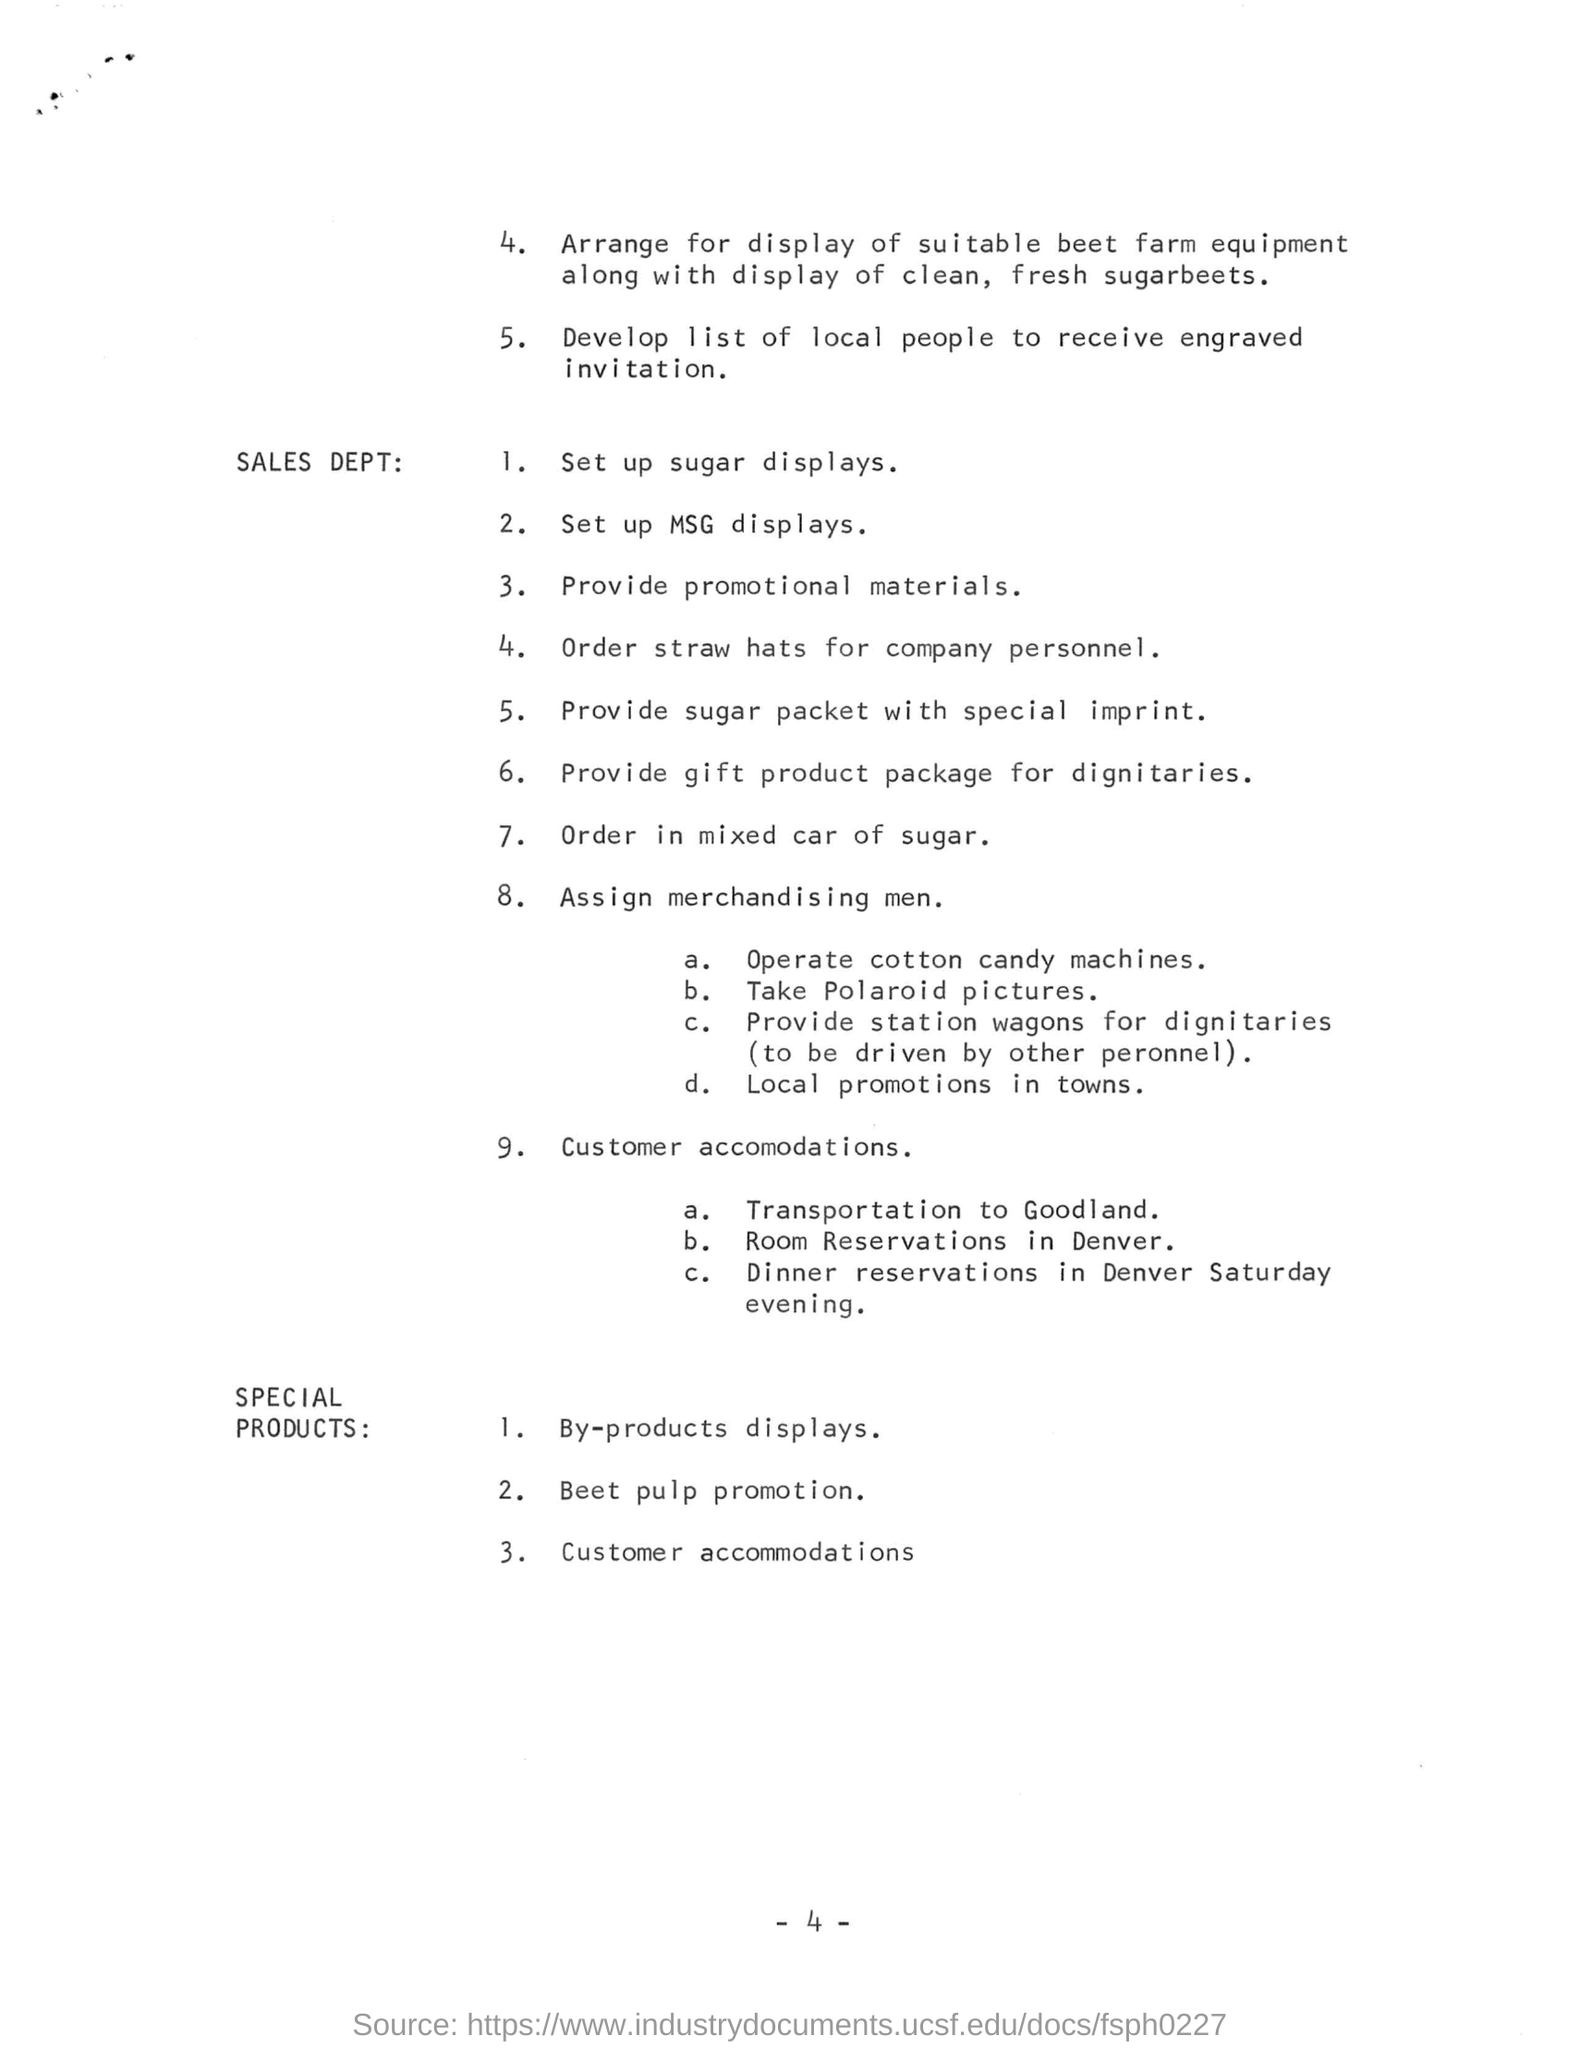What is arranged along with the display of clean, fresh sugar beets?
Your answer should be very brief. SUITABLE BEET FARM EQUIPMENT. In customer accommodation where is the transportation arranged to?
Make the answer very short. Goodland. In customer accommodation where is the room reservation arranged in?
Give a very brief answer. Denver. Which product promotion is mentioned in the SPECIAL PRODUCTS section
Provide a short and direct response. Beet pulp. 